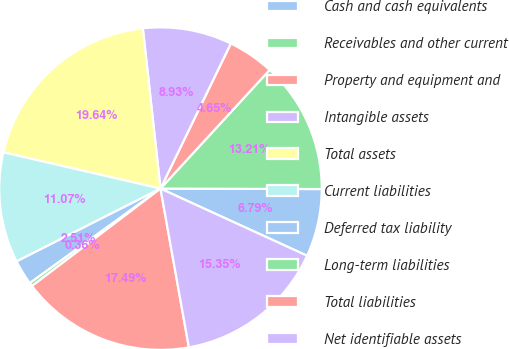Convert chart to OTSL. <chart><loc_0><loc_0><loc_500><loc_500><pie_chart><fcel>Cash and cash equivalents<fcel>Receivables and other current<fcel>Property and equipment and<fcel>Intangible assets<fcel>Total assets<fcel>Current liabilities<fcel>Deferred tax liability<fcel>Long-term liabilities<fcel>Total liabilities<fcel>Net identifiable assets<nl><fcel>6.79%<fcel>13.21%<fcel>4.65%<fcel>8.93%<fcel>19.64%<fcel>11.07%<fcel>2.51%<fcel>0.36%<fcel>17.49%<fcel>15.35%<nl></chart> 